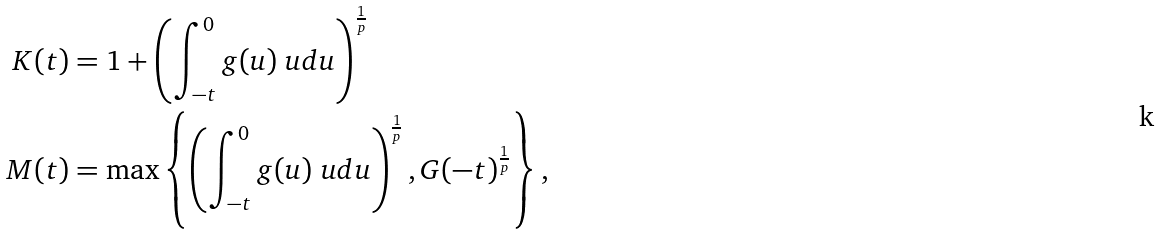Convert formula to latex. <formula><loc_0><loc_0><loc_500><loc_500>K ( t ) & = 1 + \left ( \int _ { - t } ^ { 0 } g ( u ) \ u d u \right ) ^ { \frac { 1 } { p } } \\ M ( t ) & = \max \left \{ \left ( \int _ { - t } ^ { 0 } g ( u ) \ u d u \right ) ^ { \frac { 1 } { p } } , G ( - t ) ^ { \frac { 1 } { p } } \right \} ,</formula> 